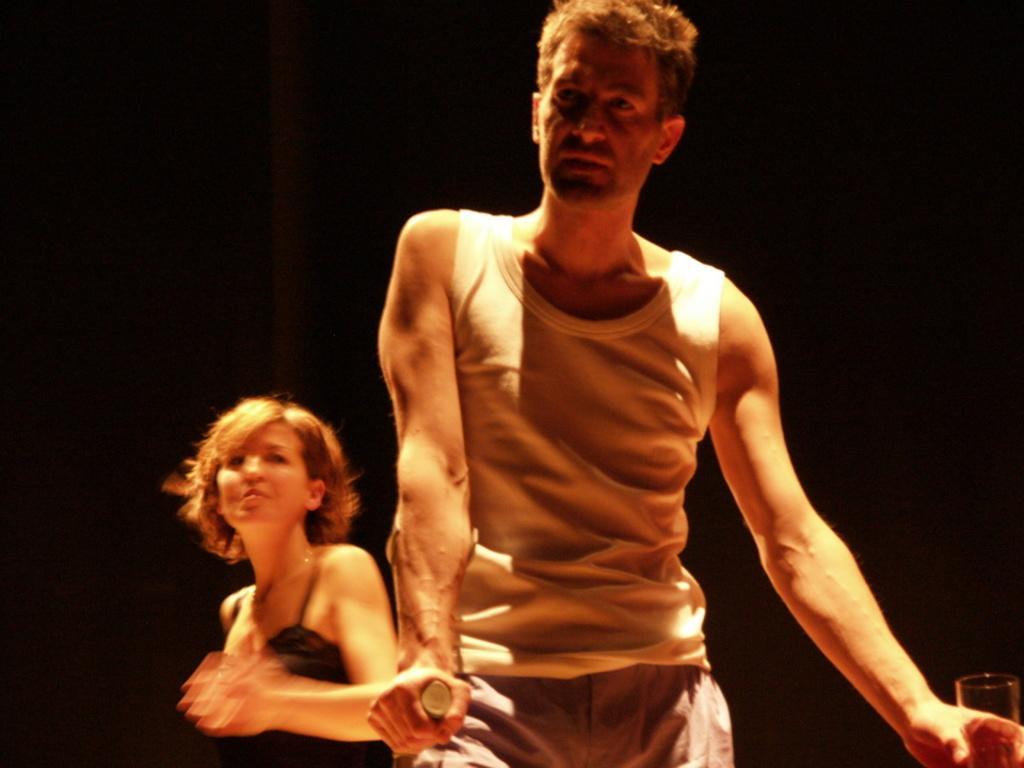Could you give a brief overview of what you see in this image? In the picture we can see a man standing and holding a glass and behind him we can see a woman standing, she is with black top and behind them we can see dark. 